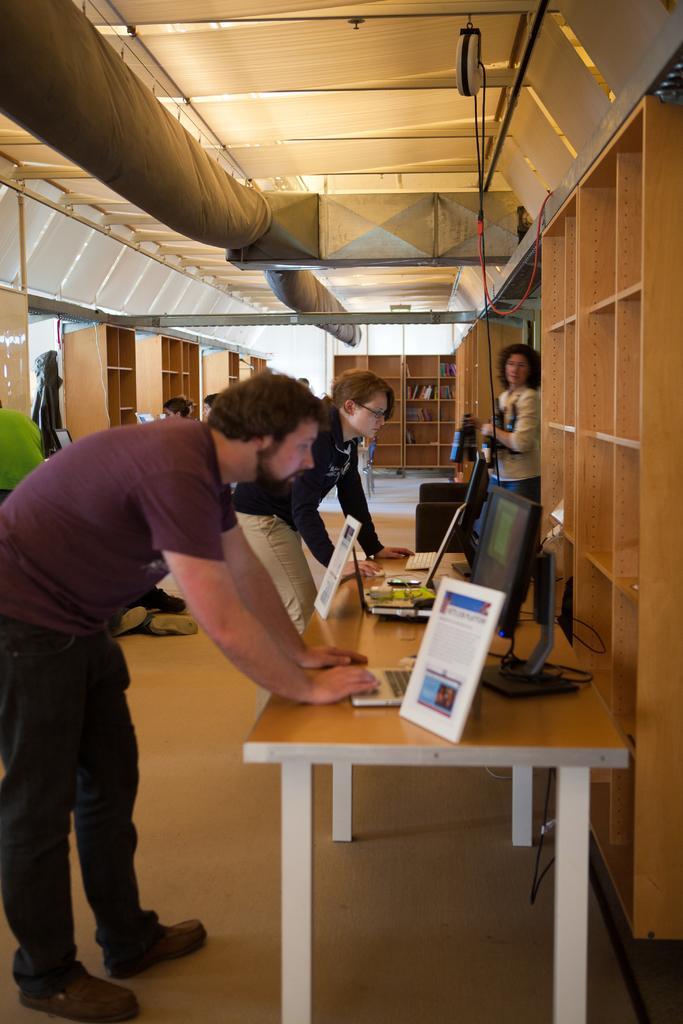In one or two sentences, can you explain what this image depicts? There are two people standing and looking on the computer. This is a table with a frame,monitors and laptops on the table. Here is the woman standing. These are the racks. At background i can see some objects placed inside the rack. This is the rooftop. 